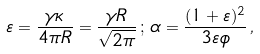Convert formula to latex. <formula><loc_0><loc_0><loc_500><loc_500>\varepsilon = \frac { \gamma \kappa } { 4 \pi R } = \frac { \gamma R } { \sqrt { 2 \pi } } \, ; \, \alpha = \frac { ( 1 + \varepsilon ) ^ { 2 } } { 3 \varepsilon \phi } \, ,</formula> 